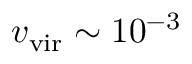<formula> <loc_0><loc_0><loc_500><loc_500>v _ { v i r } \sim 1 0 ^ { - 3 }</formula> 